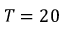<formula> <loc_0><loc_0><loc_500><loc_500>T = 2 0</formula> 